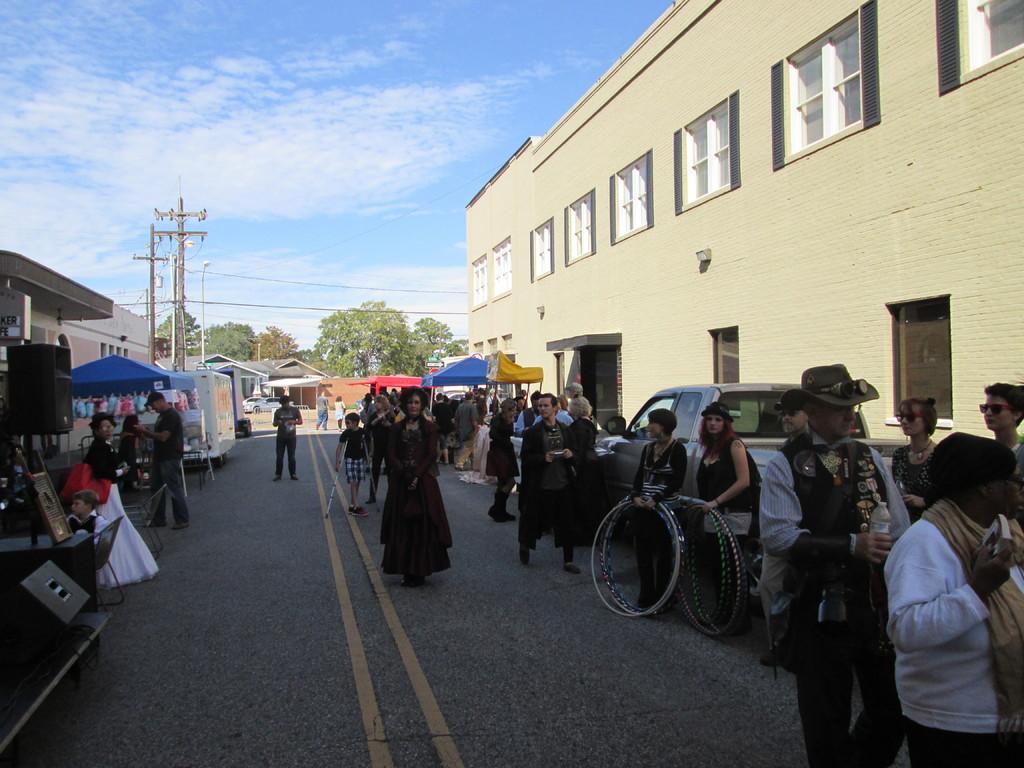In one or two sentences, can you explain what this image depicts? In the center of the image there is a road. There are people. There are vehicles. There are stalls. To the right side of the image there is a building with windows. In the background of the image there are trees, electric poles and wires. There is sky with clouds. To the left side of the image there is a house. 